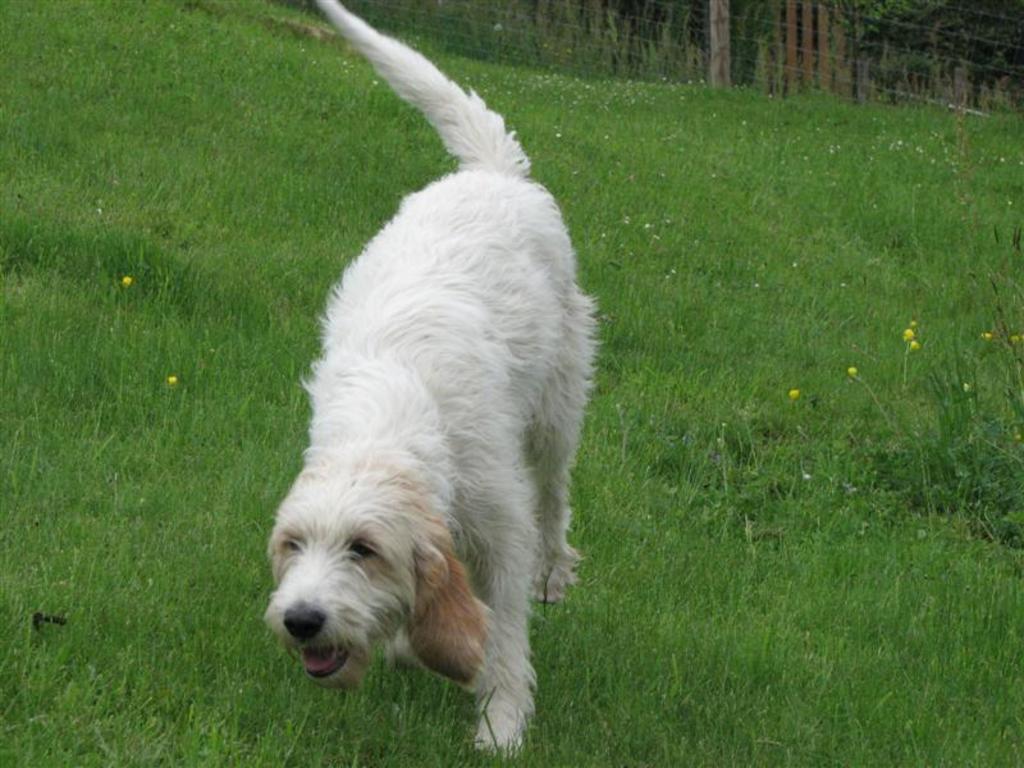Describe this image in one or two sentences. In the picture there is a dog in a garden, it is of white color and there is a fencing behind the garden. 